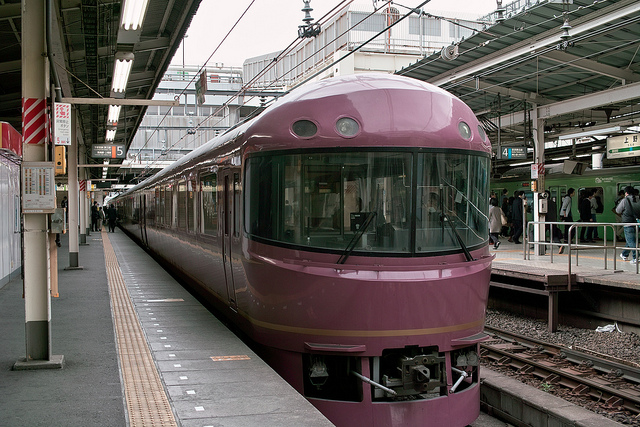<image>Why is the train at platform 5? I don't know why the train is at platform 5. It might be to pick up or let off passengers, or loading. Why is the train at platform 5? I don't know why the train is at platform 5. It can be to pick people up, to pick up passengers, to load and unload passengers, or for other reasons. 